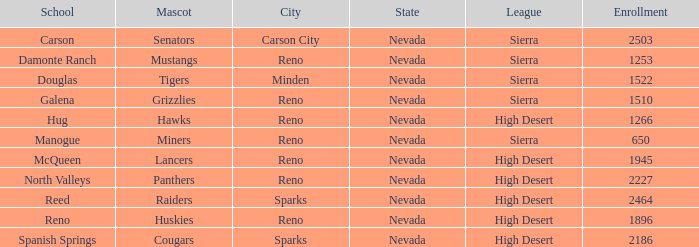In what city and state are the miners situated? Reno, Nevada. 